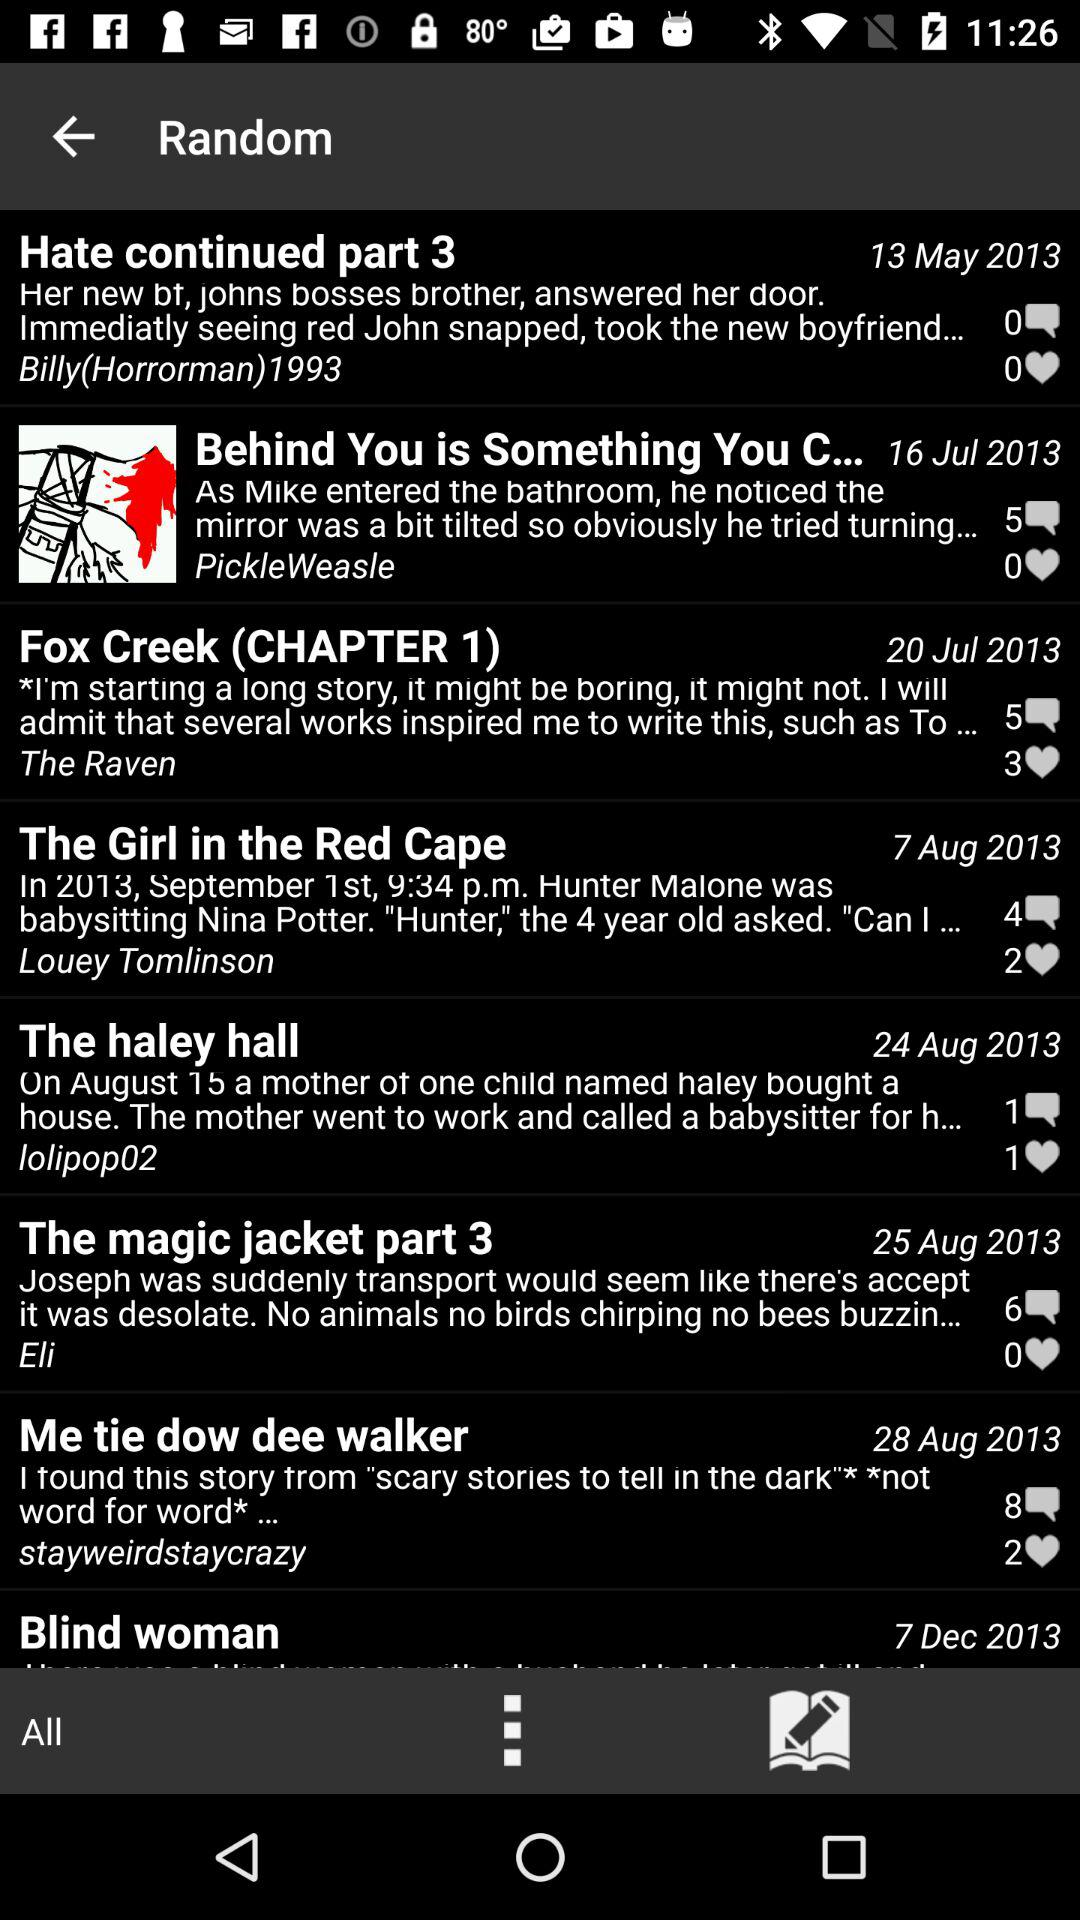How many reposts are on "Hate continued part 3"?
When the provided information is insufficient, respond with <no answer>. <no answer> 